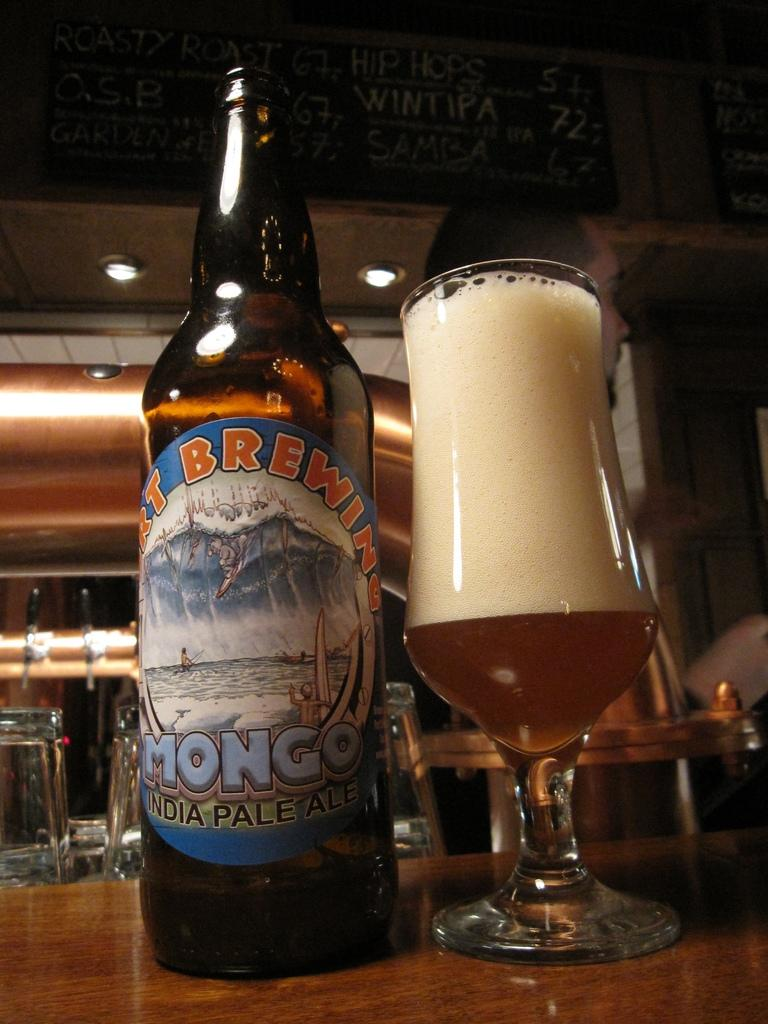<image>
Create a compact narrative representing the image presented. A bottle of beer with the word mongo on it next to a full glass of beer. 